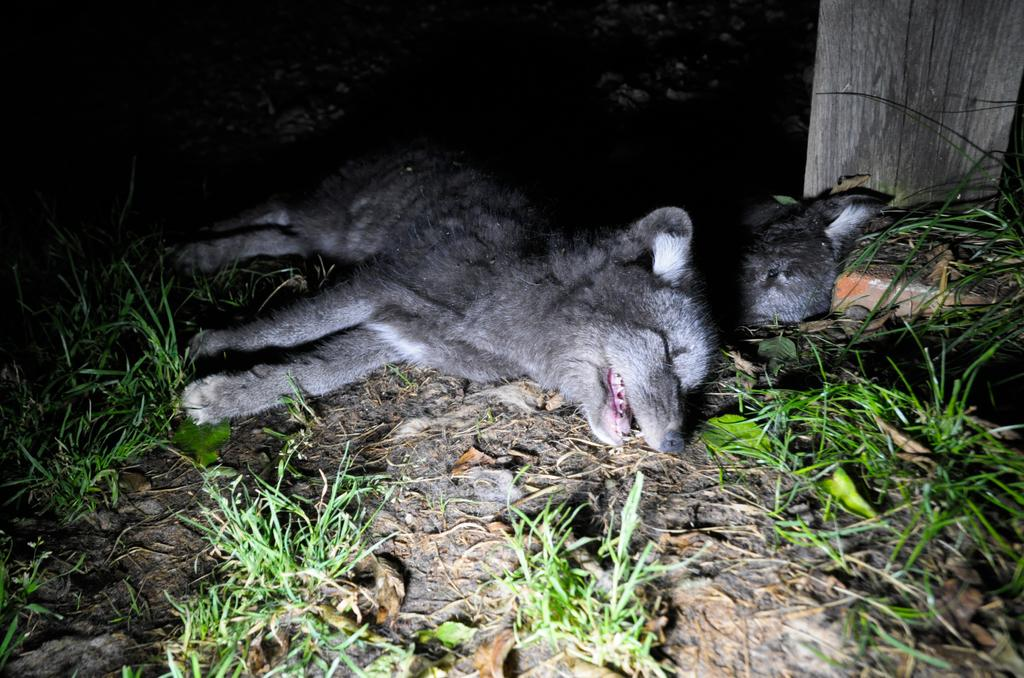What type of surface is at the bottom of the image? There is a ground with grass at the bottom of the image. What are the two animals doing in the image? The two animals are sleeping on the grass. Can you describe the wooden item in the image? Unfortunately, there is no information about a wooden item in the provided facts. How are the animals pushing the mountain in the image? There is no mountain present in the image, and the animals are sleeping on the grass, not pushing anything. 